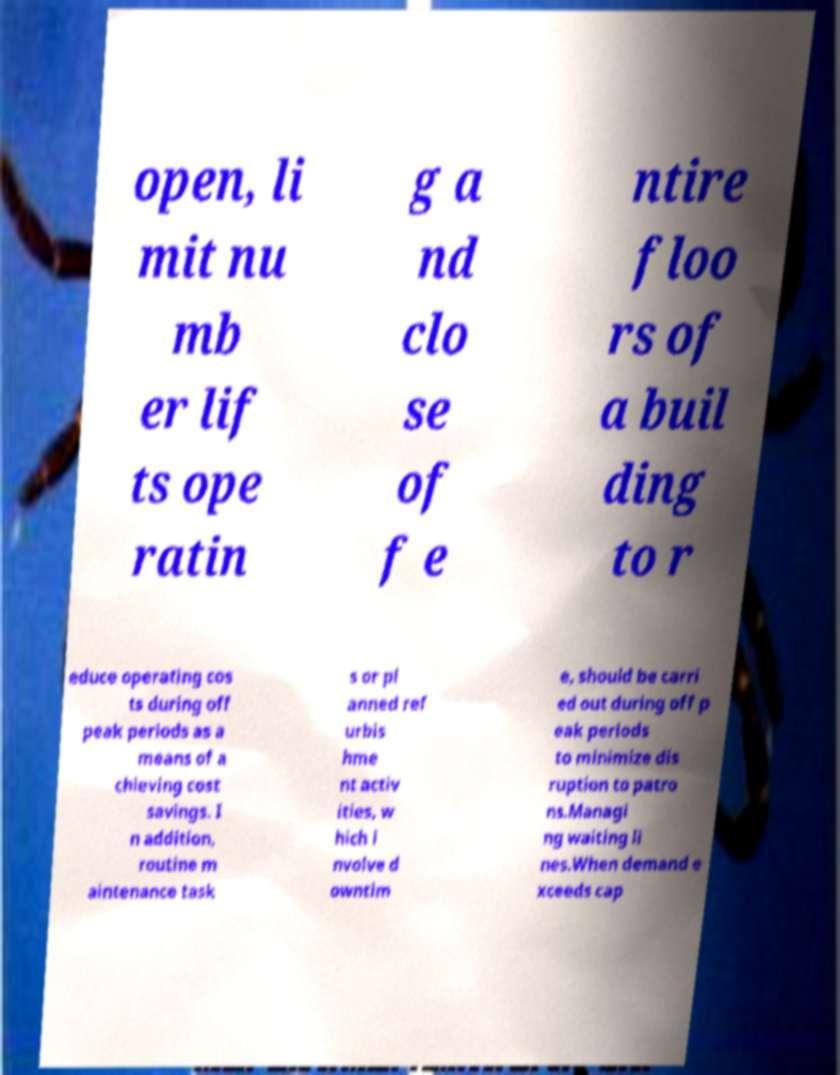There's text embedded in this image that I need extracted. Can you transcribe it verbatim? open, li mit nu mb er lif ts ope ratin g a nd clo se of f e ntire floo rs of a buil ding to r educe operating cos ts during off peak periods as a means of a chieving cost savings. I n addition, routine m aintenance task s or pl anned ref urbis hme nt activ ities, w hich i nvolve d owntim e, should be carri ed out during off p eak periods to minimize dis ruption to patro ns.Managi ng waiting li nes.When demand e xceeds cap 